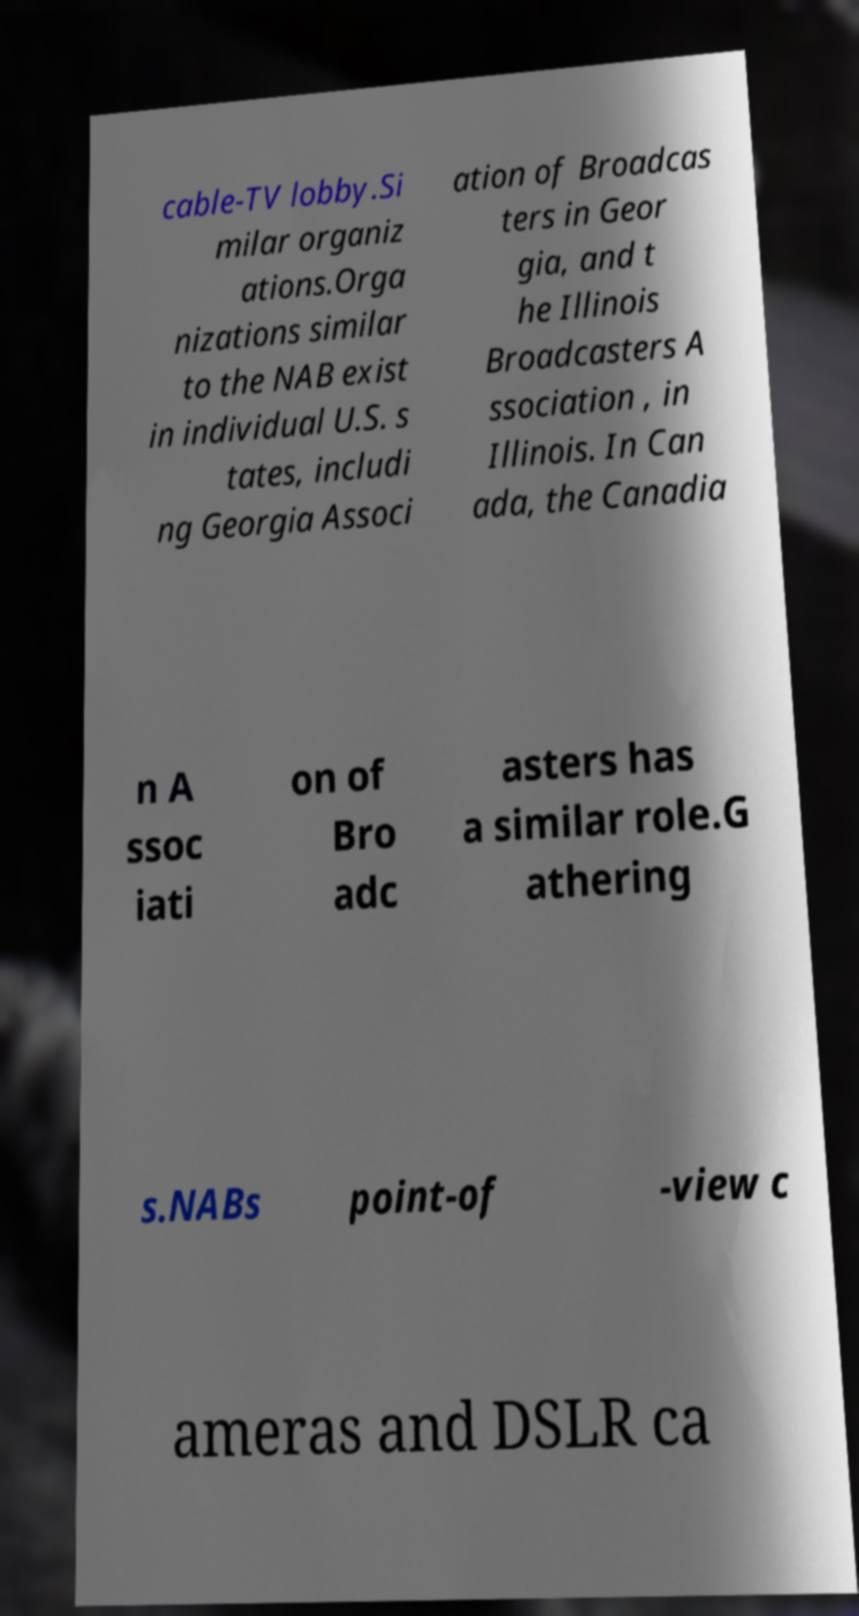Please identify and transcribe the text found in this image. cable-TV lobby.Si milar organiz ations.Orga nizations similar to the NAB exist in individual U.S. s tates, includi ng Georgia Associ ation of Broadcas ters in Geor gia, and t he Illinois Broadcasters A ssociation , in Illinois. In Can ada, the Canadia n A ssoc iati on of Bro adc asters has a similar role.G athering s.NABs point-of -view c ameras and DSLR ca 